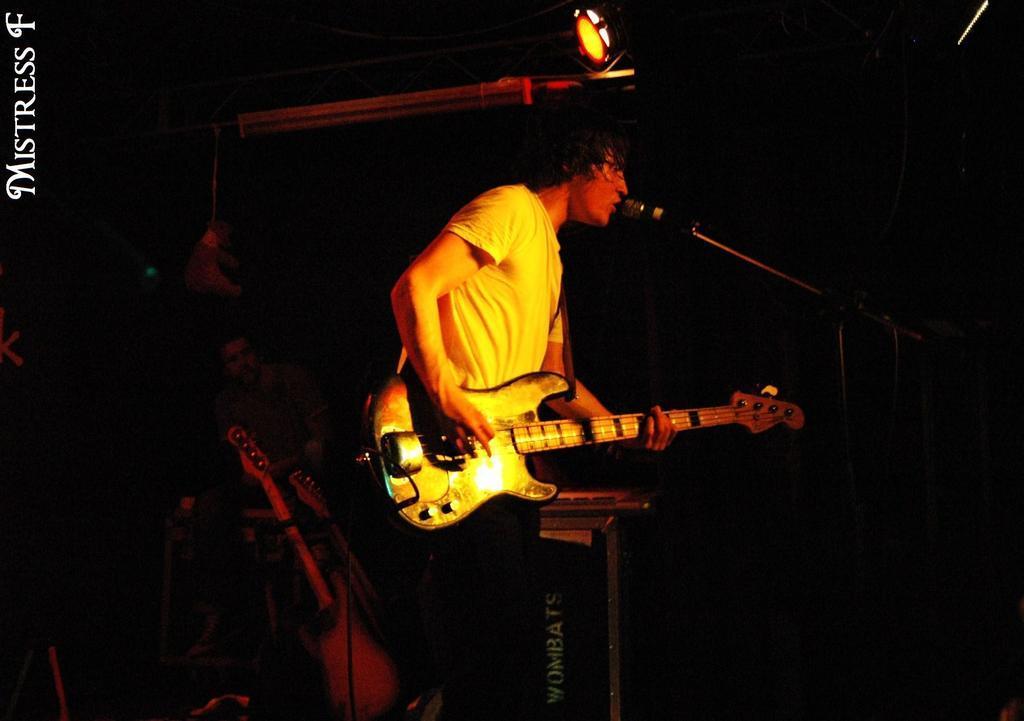Describe this image in one or two sentences. This picture show about a boy wearing white color t- shirt playing the guitar and singing in the microphone. Behind we can see another boy sitting on the chair and playing guitar. 